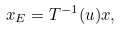Convert formula to latex. <formula><loc_0><loc_0><loc_500><loc_500>x _ { E } = T ^ { - 1 } ( u ) x ,</formula> 